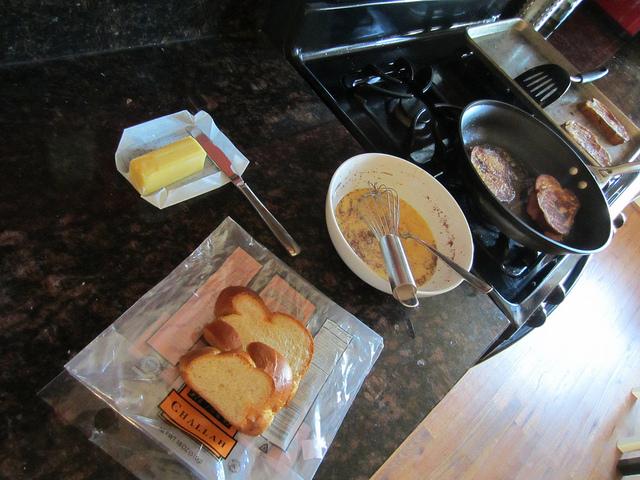Where is the knife?
Give a very brief answer. Butter. What kind of pan is on the stove?
Write a very short answer. Frying pan. What type of toast is being made?
Keep it brief. French. 